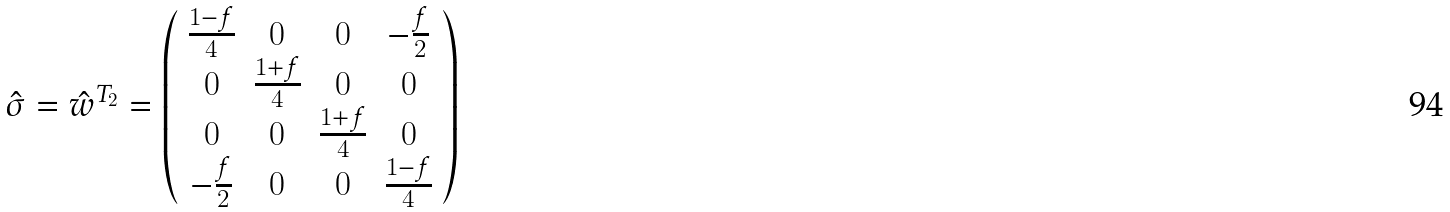Convert formula to latex. <formula><loc_0><loc_0><loc_500><loc_500>\hat { \sigma } = \hat { w } ^ { T _ { 2 } } = \left ( \begin{array} { c c c c } \frac { 1 - f } { 4 } & 0 & 0 & - \frac { f } { 2 } \\ 0 & \frac { 1 + f } { 4 } & 0 & 0 \\ 0 & 0 & \frac { 1 + f } { 4 } & 0 \\ - \frac { f } { 2 } & 0 & 0 & \frac { 1 - f } { 4 } \\ \end{array} \right )</formula> 